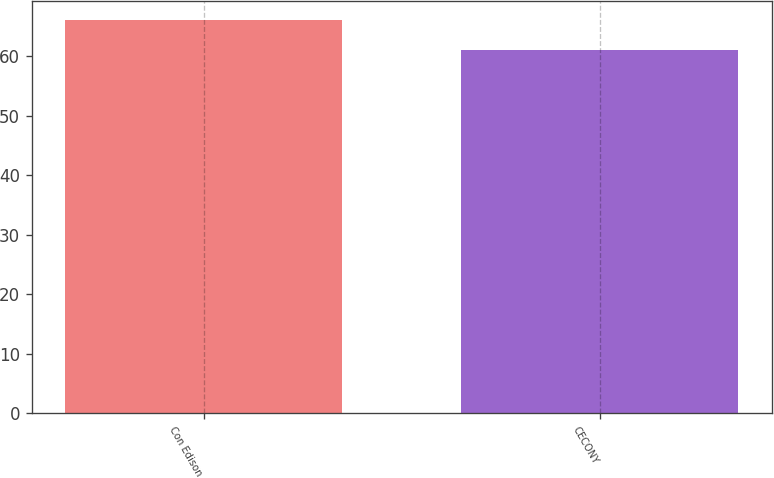Convert chart to OTSL. <chart><loc_0><loc_0><loc_500><loc_500><bar_chart><fcel>Con Edison<fcel>CECONY<nl><fcel>66<fcel>61<nl></chart> 